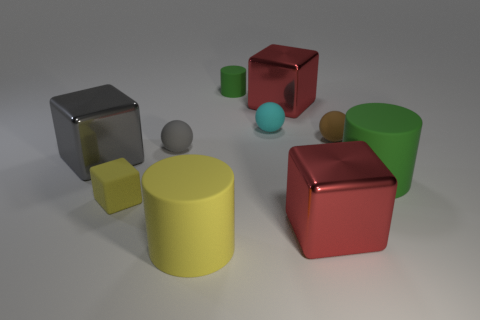What is the shape of the tiny yellow thing that is the same material as the large green object?
Your response must be concise. Cube. What number of large metallic blocks are behind the small rubber cube and right of the cyan sphere?
Provide a succinct answer. 1. Are there any red objects in front of the tiny cube?
Your answer should be compact. Yes. There is a yellow thing to the left of the yellow cylinder; does it have the same shape as the gray thing in front of the small gray matte thing?
Your answer should be very brief. Yes. What number of objects are purple balls or blocks in front of the brown sphere?
Offer a very short reply. 3. How many other things are there of the same shape as the big yellow rubber thing?
Your answer should be very brief. 2. Are the green object on the left side of the big green thing and the big green cylinder made of the same material?
Your answer should be compact. Yes. How many objects are large yellow rubber cylinders or small green objects?
Ensure brevity in your answer.  2. The yellow rubber thing that is the same shape as the big gray metal thing is what size?
Provide a short and direct response. Small. The gray metal cube is what size?
Offer a very short reply. Large. 